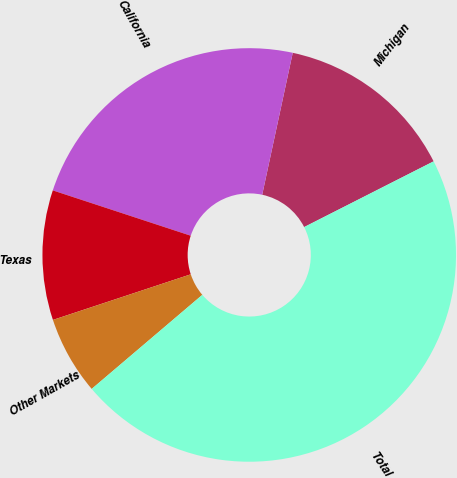Convert chart to OTSL. <chart><loc_0><loc_0><loc_500><loc_500><pie_chart><fcel>Michigan<fcel>California<fcel>Texas<fcel>Other Markets<fcel>Total<nl><fcel>14.15%<fcel>23.32%<fcel>10.14%<fcel>6.13%<fcel>46.26%<nl></chart> 